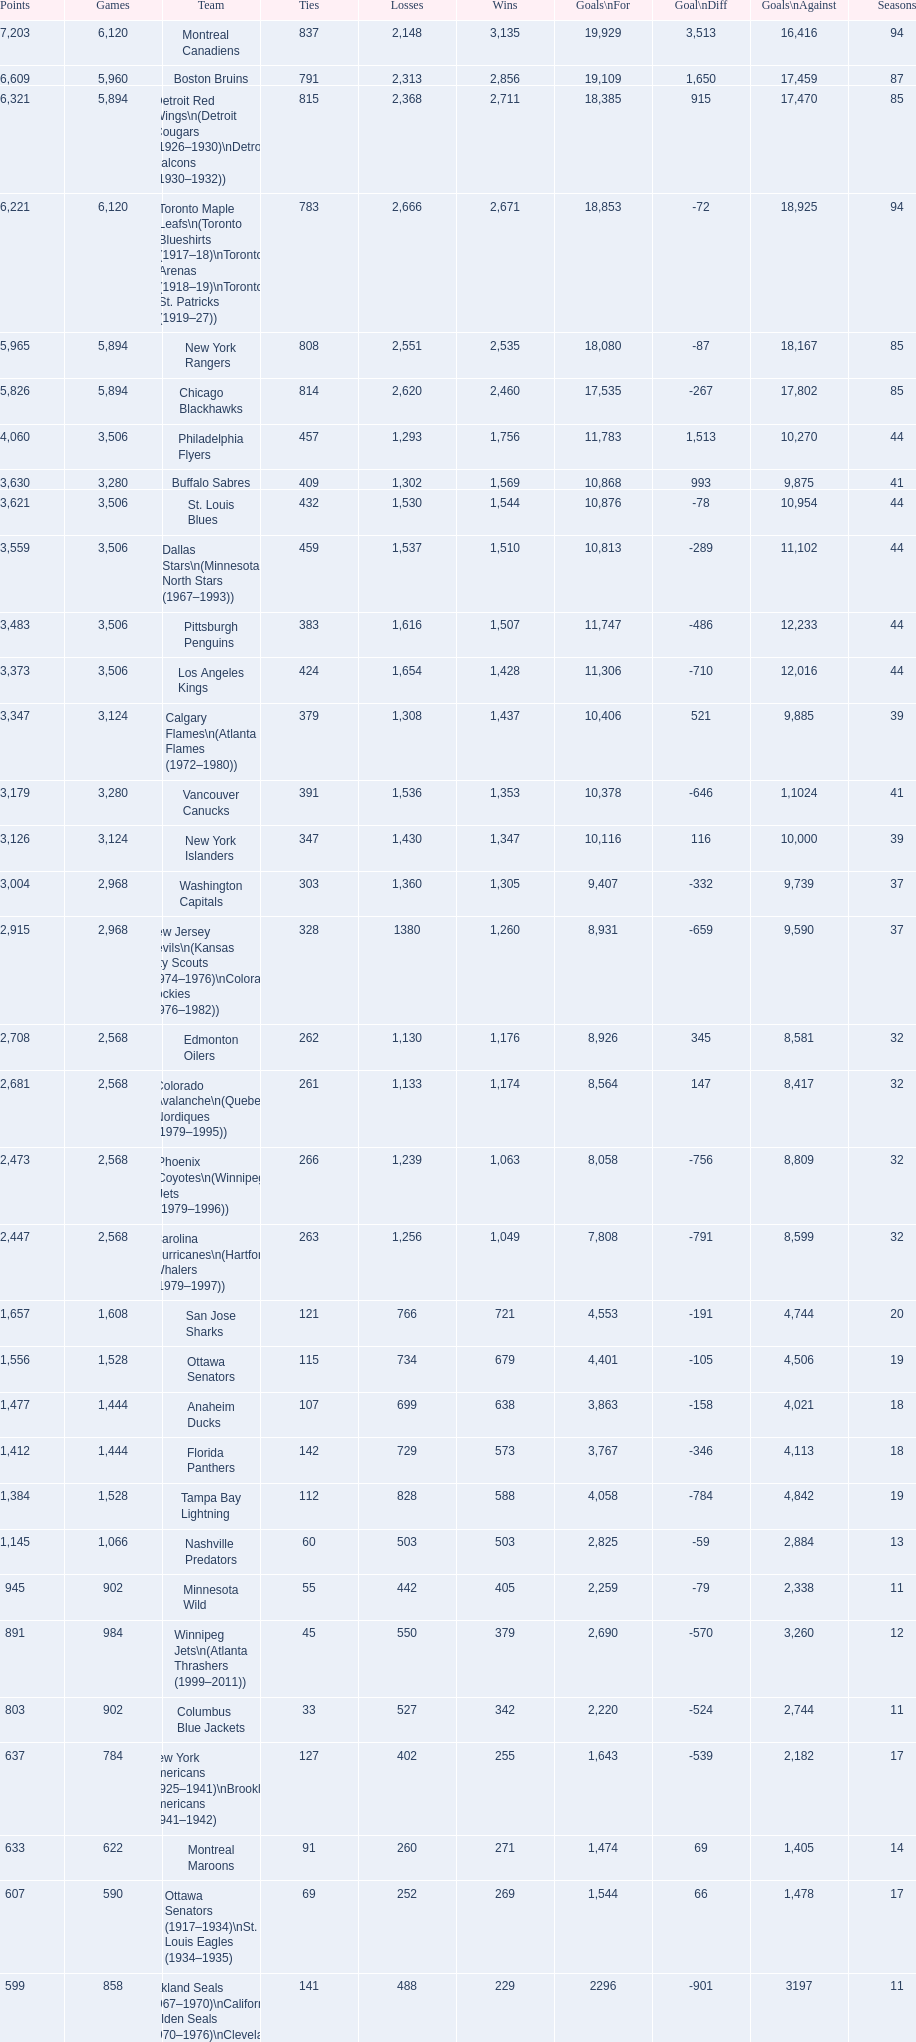How many losses do the st. louis blues have? 1,530. 